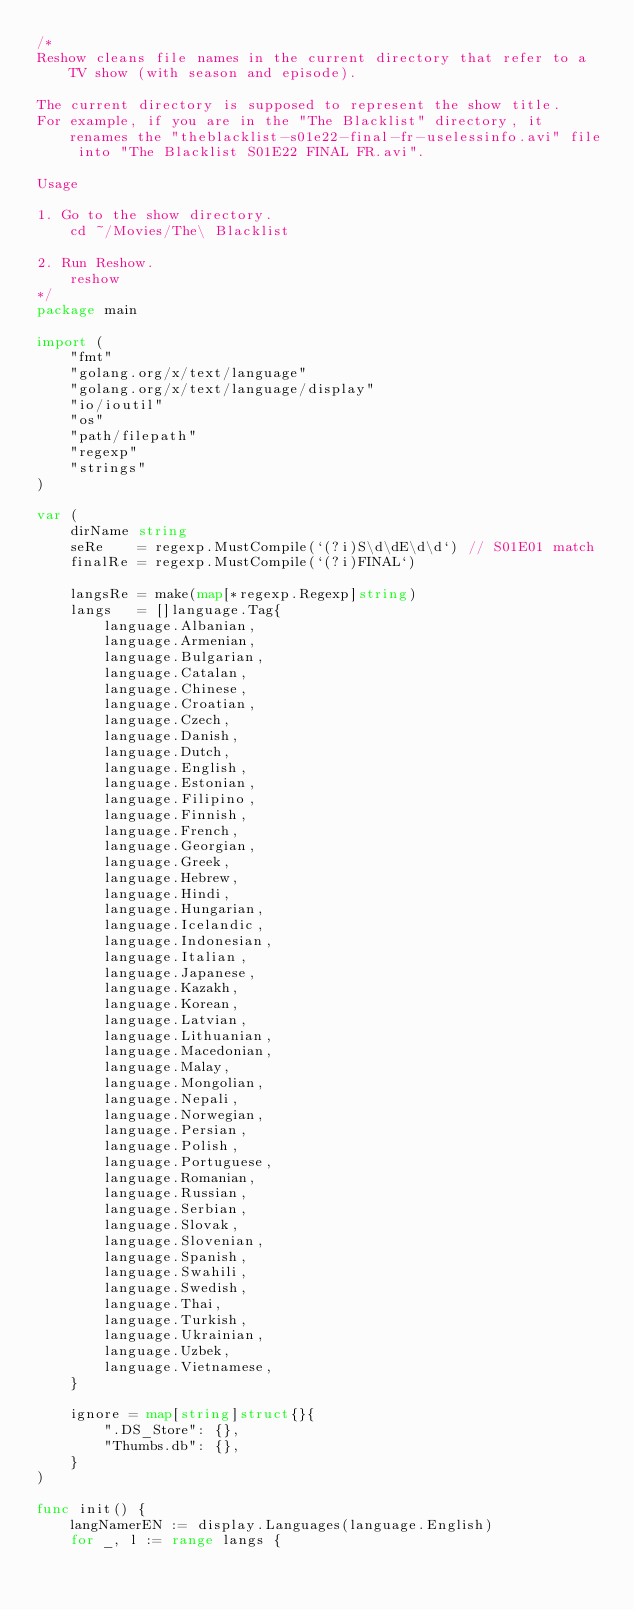Convert code to text. <code><loc_0><loc_0><loc_500><loc_500><_Go_>/*
Reshow cleans file names in the current directory that refer to a TV show (with season and episode).

The current directory is supposed to represent the show title.
For example, if you are in the "The Blacklist" directory, it renames the "theblacklist-s01e22-final-fr-uselessinfo.avi" file into "The Blacklist S01E22 FINAL FR.avi".

Usage

1. Go to the show directory.
	cd ~/Movies/The\ Blacklist

2. Run Reshow.
	reshow
*/
package main

import (
	"fmt"
	"golang.org/x/text/language"
	"golang.org/x/text/language/display"
	"io/ioutil"
	"os"
	"path/filepath"
	"regexp"
	"strings"
)

var (
	dirName string
	seRe    = regexp.MustCompile(`(?i)S\d\dE\d\d`) // S01E01 match
	finalRe = regexp.MustCompile(`(?i)FINAL`)

	langsRe = make(map[*regexp.Regexp]string)
	langs   = []language.Tag{
		language.Albanian,
		language.Armenian,
		language.Bulgarian,
		language.Catalan,
		language.Chinese,
		language.Croatian,
		language.Czech,
		language.Danish,
		language.Dutch,
		language.English,
		language.Estonian,
		language.Filipino,
		language.Finnish,
		language.French,
		language.Georgian,
		language.Greek,
		language.Hebrew,
		language.Hindi,
		language.Hungarian,
		language.Icelandic,
		language.Indonesian,
		language.Italian,
		language.Japanese,
		language.Kazakh,
		language.Korean,
		language.Latvian,
		language.Lithuanian,
		language.Macedonian,
		language.Malay,
		language.Mongolian,
		language.Nepali,
		language.Norwegian,
		language.Persian,
		language.Polish,
		language.Portuguese,
		language.Romanian,
		language.Russian,
		language.Serbian,
		language.Slovak,
		language.Slovenian,
		language.Spanish,
		language.Swahili,
		language.Swedish,
		language.Thai,
		language.Turkish,
		language.Ukrainian,
		language.Uzbek,
		language.Vietnamese,
	}

	ignore = map[string]struct{}{
		".DS_Store": {},
		"Thumbs.db": {},
	}
)

func init() {
	langNamerEN := display.Languages(language.English)
	for _, l := range langs {</code> 